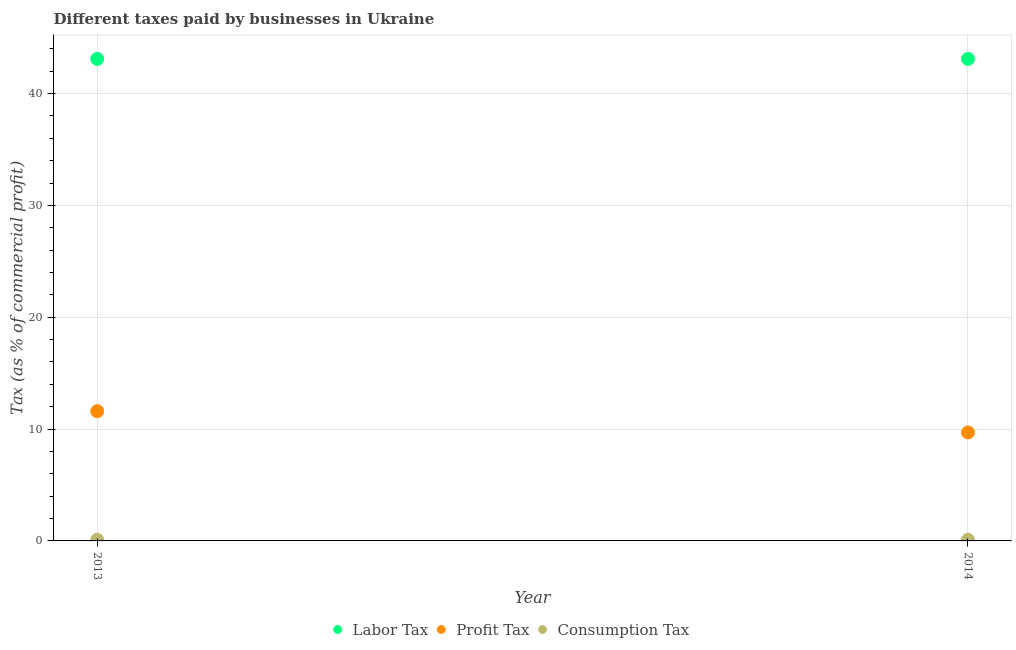What is the percentage of labor tax in 2013?
Your response must be concise. 43.1. Across all years, what is the maximum percentage of profit tax?
Your answer should be very brief. 11.6. Across all years, what is the minimum percentage of labor tax?
Offer a terse response. 43.1. In which year was the percentage of consumption tax minimum?
Offer a very short reply. 2013. What is the total percentage of labor tax in the graph?
Your answer should be very brief. 86.2. What is the difference between the percentage of consumption tax in 2014 and the percentage of labor tax in 2013?
Make the answer very short. -43. What is the average percentage of profit tax per year?
Your answer should be very brief. 10.65. In the year 2013, what is the difference between the percentage of profit tax and percentage of labor tax?
Provide a succinct answer. -31.5. In how many years, is the percentage of consumption tax greater than 28 %?
Provide a succinct answer. 0. What is the ratio of the percentage of profit tax in 2013 to that in 2014?
Ensure brevity in your answer.  1.2. Is the percentage of labor tax in 2013 less than that in 2014?
Your response must be concise. No. In how many years, is the percentage of labor tax greater than the average percentage of labor tax taken over all years?
Offer a very short reply. 0. Is it the case that in every year, the sum of the percentage of labor tax and percentage of profit tax is greater than the percentage of consumption tax?
Keep it short and to the point. Yes. Does the percentage of consumption tax monotonically increase over the years?
Ensure brevity in your answer.  No. Is the percentage of labor tax strictly less than the percentage of consumption tax over the years?
Your response must be concise. No. How many dotlines are there?
Make the answer very short. 3. What is the difference between two consecutive major ticks on the Y-axis?
Keep it short and to the point. 10. Does the graph contain grids?
Ensure brevity in your answer.  Yes. Where does the legend appear in the graph?
Provide a short and direct response. Bottom center. How many legend labels are there?
Keep it short and to the point. 3. How are the legend labels stacked?
Your answer should be very brief. Horizontal. What is the title of the graph?
Keep it short and to the point. Different taxes paid by businesses in Ukraine. Does "Taxes on international trade" appear as one of the legend labels in the graph?
Keep it short and to the point. No. What is the label or title of the Y-axis?
Offer a terse response. Tax (as % of commercial profit). What is the Tax (as % of commercial profit) in Labor Tax in 2013?
Give a very brief answer. 43.1. What is the Tax (as % of commercial profit) of Consumption Tax in 2013?
Give a very brief answer. 0.1. What is the Tax (as % of commercial profit) of Labor Tax in 2014?
Ensure brevity in your answer.  43.1. What is the Tax (as % of commercial profit) in Consumption Tax in 2014?
Provide a succinct answer. 0.1. Across all years, what is the maximum Tax (as % of commercial profit) in Labor Tax?
Your response must be concise. 43.1. Across all years, what is the maximum Tax (as % of commercial profit) in Profit Tax?
Keep it short and to the point. 11.6. Across all years, what is the maximum Tax (as % of commercial profit) in Consumption Tax?
Ensure brevity in your answer.  0.1. Across all years, what is the minimum Tax (as % of commercial profit) of Labor Tax?
Give a very brief answer. 43.1. Across all years, what is the minimum Tax (as % of commercial profit) of Profit Tax?
Ensure brevity in your answer.  9.7. Across all years, what is the minimum Tax (as % of commercial profit) in Consumption Tax?
Offer a very short reply. 0.1. What is the total Tax (as % of commercial profit) of Labor Tax in the graph?
Keep it short and to the point. 86.2. What is the total Tax (as % of commercial profit) of Profit Tax in the graph?
Your answer should be compact. 21.3. What is the difference between the Tax (as % of commercial profit) of Labor Tax in 2013 and that in 2014?
Ensure brevity in your answer.  0. What is the difference between the Tax (as % of commercial profit) of Consumption Tax in 2013 and that in 2014?
Offer a very short reply. 0. What is the difference between the Tax (as % of commercial profit) of Labor Tax in 2013 and the Tax (as % of commercial profit) of Profit Tax in 2014?
Keep it short and to the point. 33.4. What is the average Tax (as % of commercial profit) of Labor Tax per year?
Your answer should be very brief. 43.1. What is the average Tax (as % of commercial profit) in Profit Tax per year?
Provide a short and direct response. 10.65. In the year 2013, what is the difference between the Tax (as % of commercial profit) in Labor Tax and Tax (as % of commercial profit) in Profit Tax?
Your answer should be very brief. 31.5. In the year 2013, what is the difference between the Tax (as % of commercial profit) of Labor Tax and Tax (as % of commercial profit) of Consumption Tax?
Give a very brief answer. 43. In the year 2013, what is the difference between the Tax (as % of commercial profit) in Profit Tax and Tax (as % of commercial profit) in Consumption Tax?
Your response must be concise. 11.5. In the year 2014, what is the difference between the Tax (as % of commercial profit) of Labor Tax and Tax (as % of commercial profit) of Profit Tax?
Ensure brevity in your answer.  33.4. In the year 2014, what is the difference between the Tax (as % of commercial profit) in Labor Tax and Tax (as % of commercial profit) in Consumption Tax?
Ensure brevity in your answer.  43. What is the ratio of the Tax (as % of commercial profit) in Profit Tax in 2013 to that in 2014?
Keep it short and to the point. 1.2. What is the ratio of the Tax (as % of commercial profit) in Consumption Tax in 2013 to that in 2014?
Your answer should be very brief. 1. What is the difference between the highest and the second highest Tax (as % of commercial profit) in Labor Tax?
Keep it short and to the point. 0. What is the difference between the highest and the second highest Tax (as % of commercial profit) in Profit Tax?
Make the answer very short. 1.9. What is the difference between the highest and the second highest Tax (as % of commercial profit) of Consumption Tax?
Provide a succinct answer. 0. What is the difference between the highest and the lowest Tax (as % of commercial profit) of Profit Tax?
Ensure brevity in your answer.  1.9. 